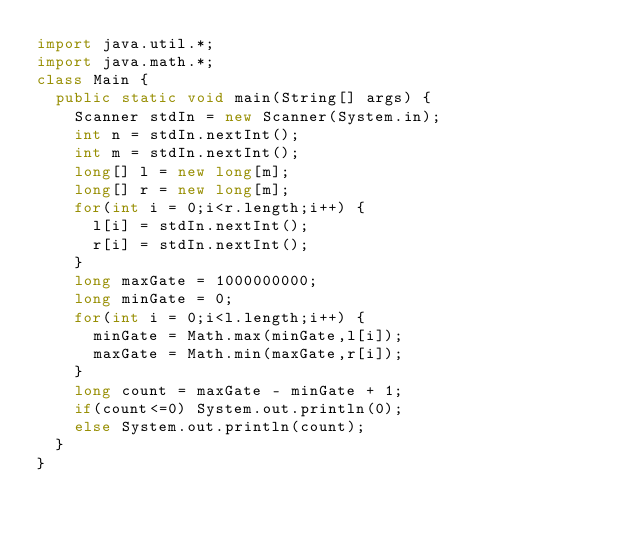Convert code to text. <code><loc_0><loc_0><loc_500><loc_500><_Java_>import java.util.*;
import java.math.*;
class Main {
  public static void main(String[] args) {
    Scanner stdIn = new Scanner(System.in);
    int n = stdIn.nextInt();
    int m = stdIn.nextInt();
    long[] l = new long[m];
    long[] r = new long[m];
    for(int i = 0;i<r.length;i++) {
      l[i] = stdIn.nextInt();
      r[i] = stdIn.nextInt();
    }
    long maxGate = 1000000000;
    long minGate = 0;
    for(int i = 0;i<l.length;i++) {
      minGate = Math.max(minGate,l[i]);
      maxGate = Math.min(maxGate,r[i]);
    }
    long count = maxGate - minGate + 1;
    if(count<=0) System.out.println(0);
    else System.out.println(count);
  }
}
</code> 